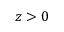Convert formula to latex. <formula><loc_0><loc_0><loc_500><loc_500>z > 0</formula> 